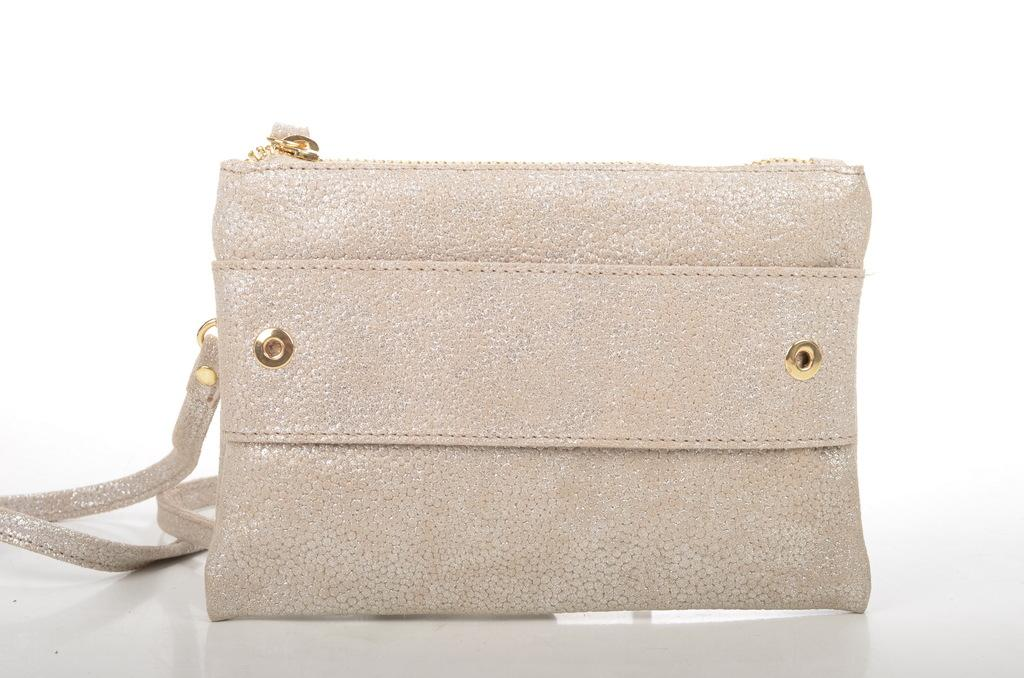What object can be seen in the image? There is a bag in the image. What is the color of the bag? The bag is shiny white in color. What feature does the bag have for closing or securing its contents? The bag has a zip. How can the bag be carried or held? The bag has a handle. How many rabbits are sitting on the note inside the bag? There is no note or rabbits present inside the bag; the image only shows a bag with a zip and handle. 